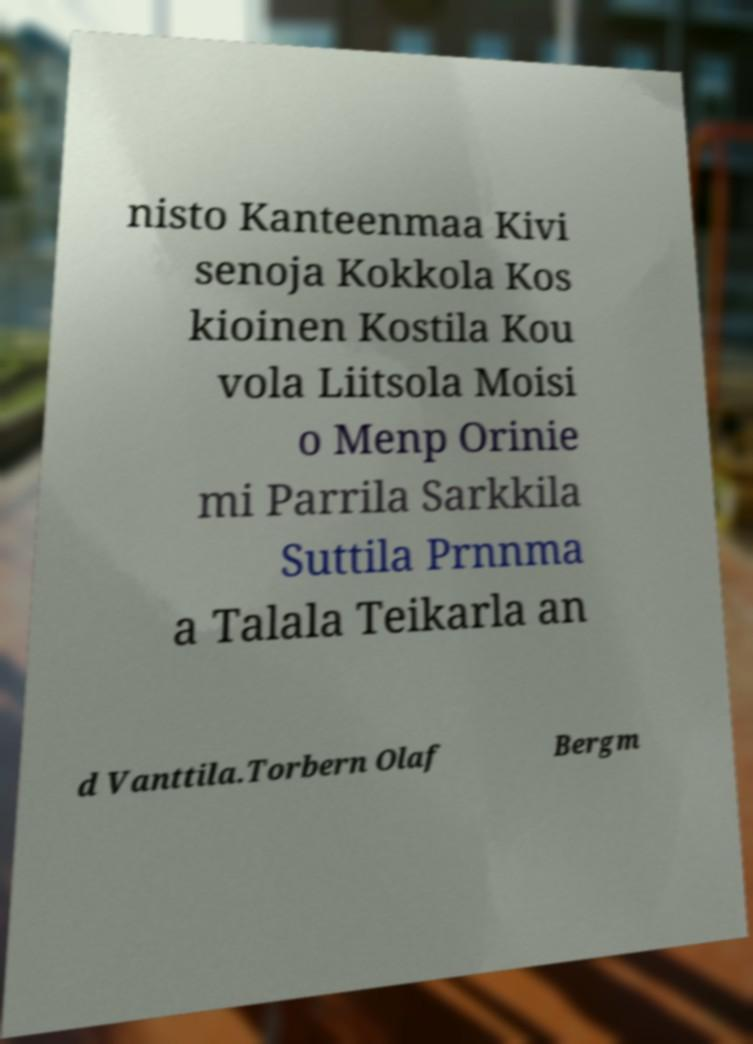Please read and relay the text visible in this image. What does it say? nisto Kanteenmaa Kivi senoja Kokkola Kos kioinen Kostila Kou vola Liitsola Moisi o Menp Orinie mi Parrila Sarkkila Suttila Prnnma a Talala Teikarla an d Vanttila.Torbern Olaf Bergm 